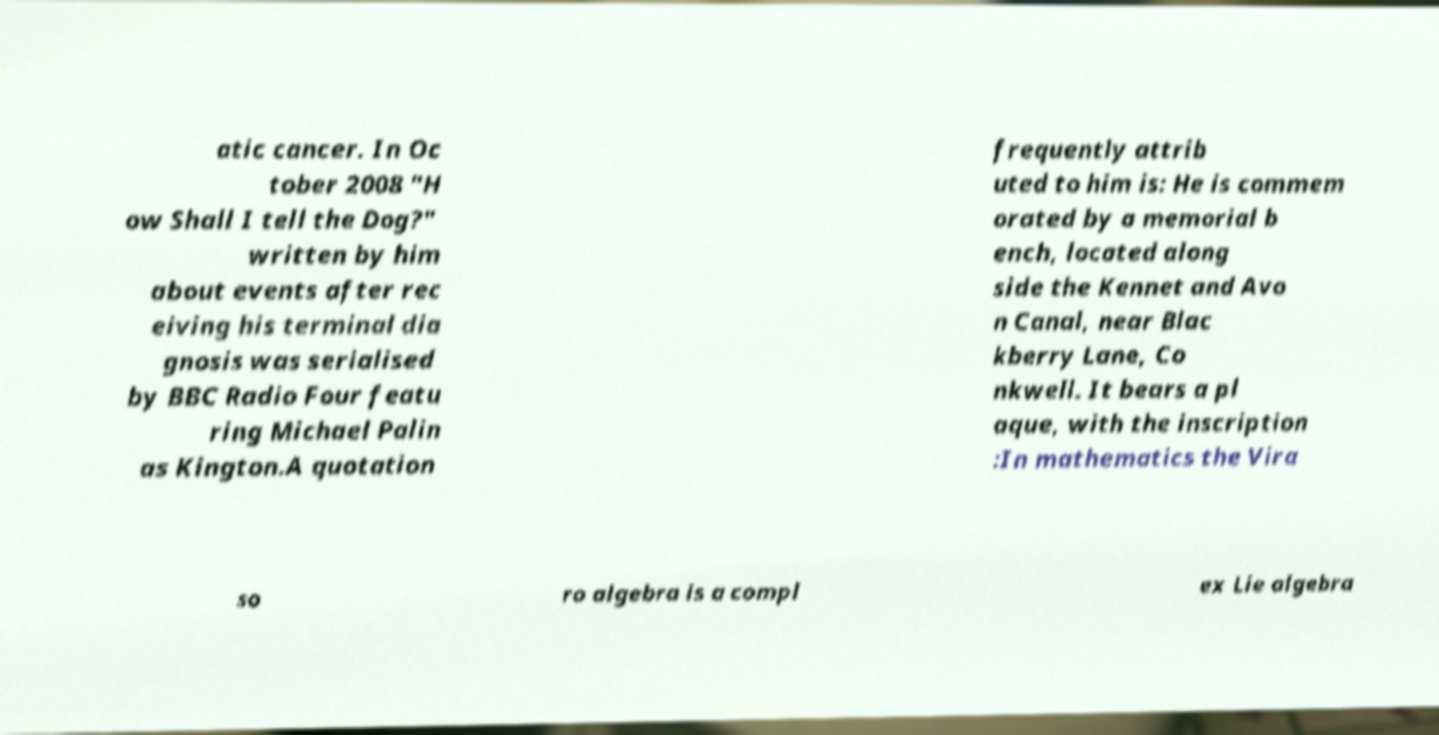Can you accurately transcribe the text from the provided image for me? atic cancer. In Oc tober 2008 "H ow Shall I tell the Dog?" written by him about events after rec eiving his terminal dia gnosis was serialised by BBC Radio Four featu ring Michael Palin as Kington.A quotation frequently attrib uted to him is: He is commem orated by a memorial b ench, located along side the Kennet and Avo n Canal, near Blac kberry Lane, Co nkwell. It bears a pl aque, with the inscription :In mathematics the Vira so ro algebra is a compl ex Lie algebra 